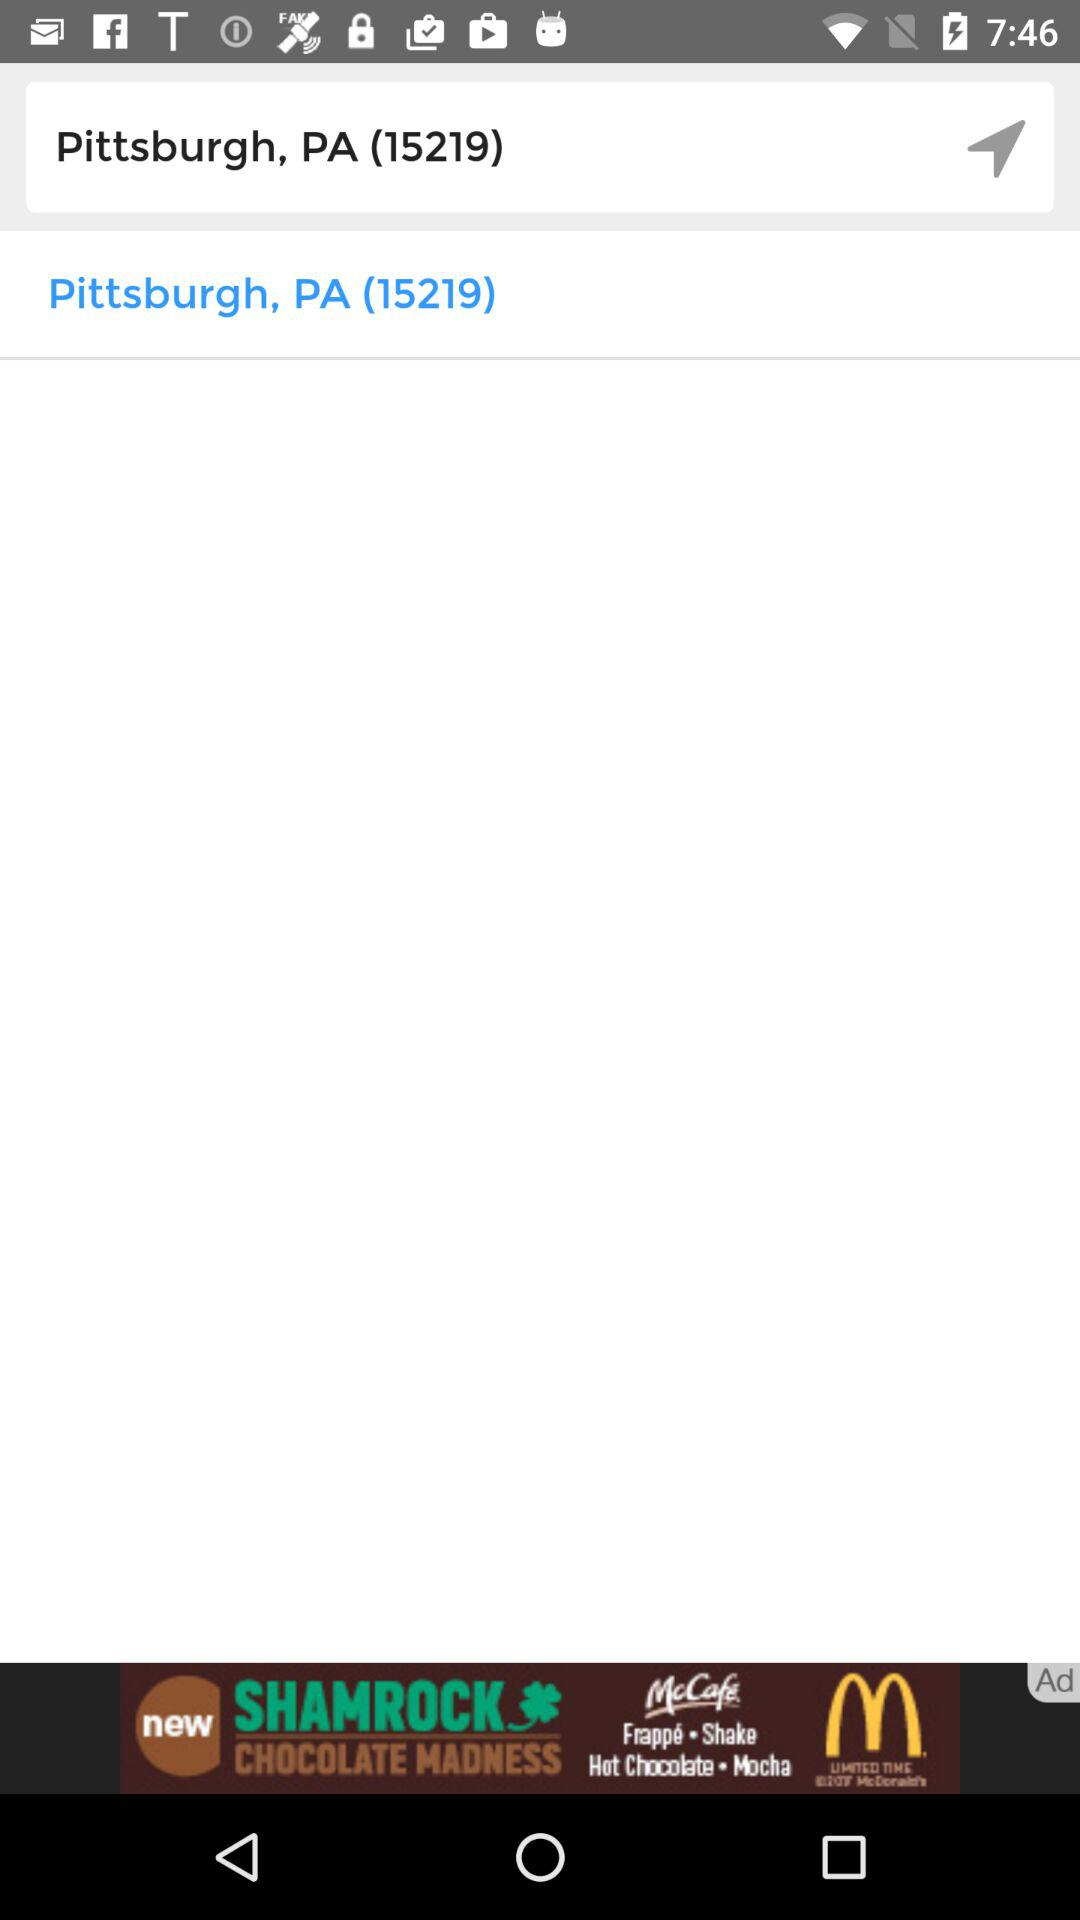What is the version of this application?
When the provided information is insufficient, respond with <no answer>. <no answer> 